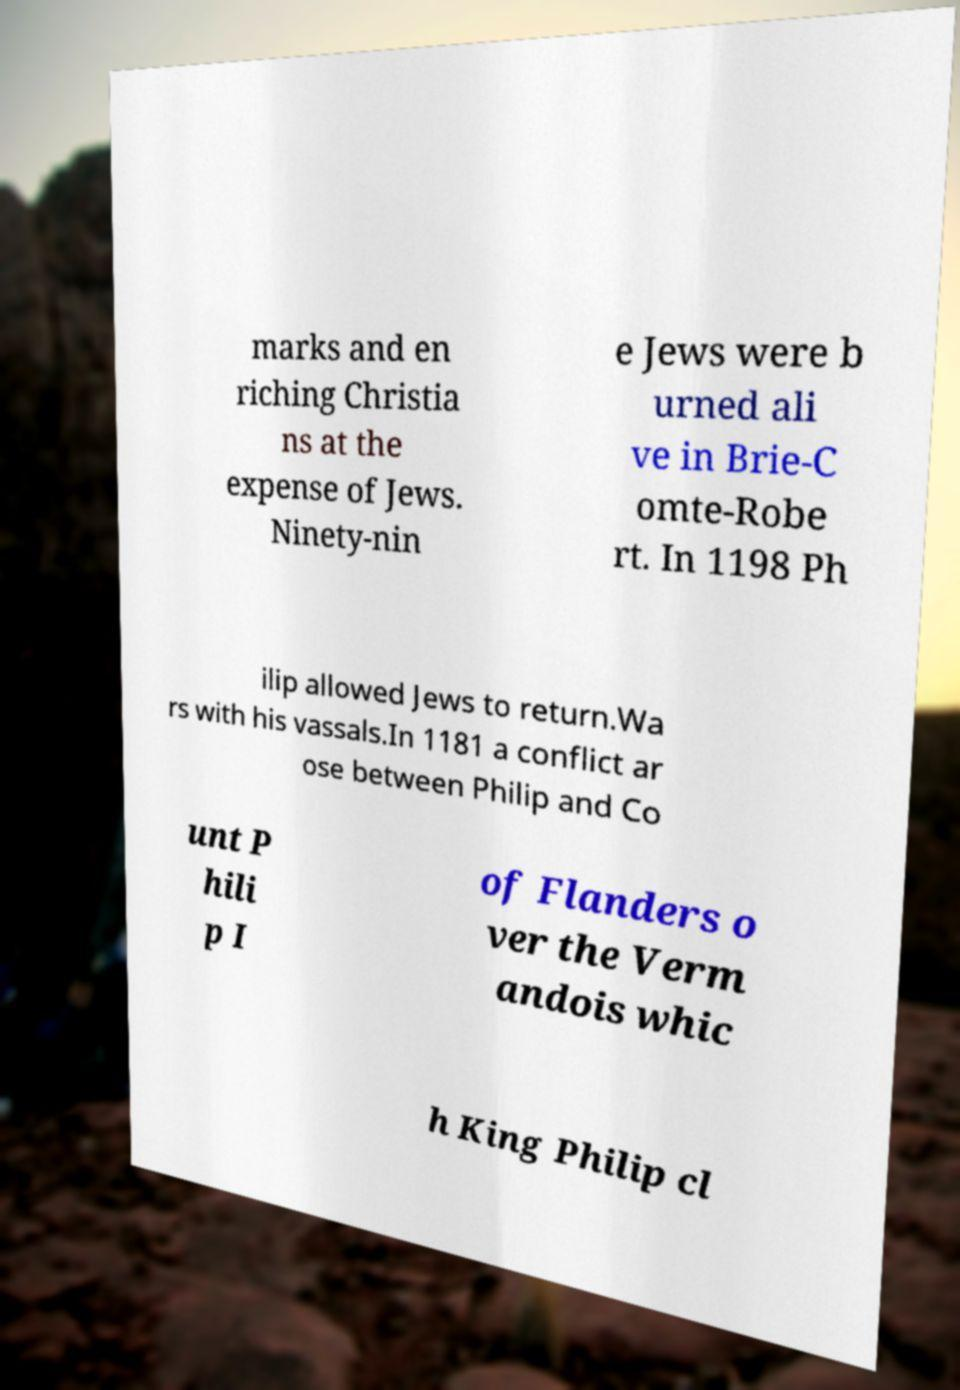Please read and relay the text visible in this image. What does it say? marks and en riching Christia ns at the expense of Jews. Ninety-nin e Jews were b urned ali ve in Brie-C omte-Robe rt. In 1198 Ph ilip allowed Jews to return.Wa rs with his vassals.In 1181 a conflict ar ose between Philip and Co unt P hili p I of Flanders o ver the Verm andois whic h King Philip cl 